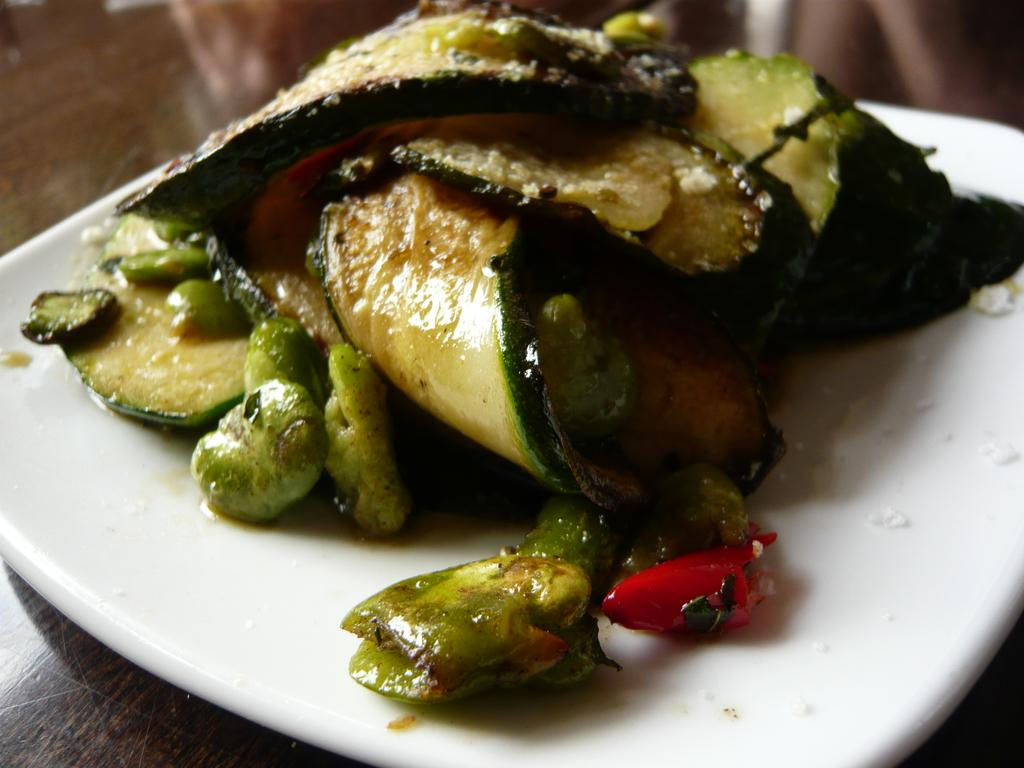What color is the plate that is visible in the image? The plate is white in color. What is on the plate in the image? There is food on the plate. Where is the plate located in the image? The plate is placed on a table. How many trains can be seen passing by the river in the image? There are no trains or rivers present in the image; it only features a white color plate with food on it. 